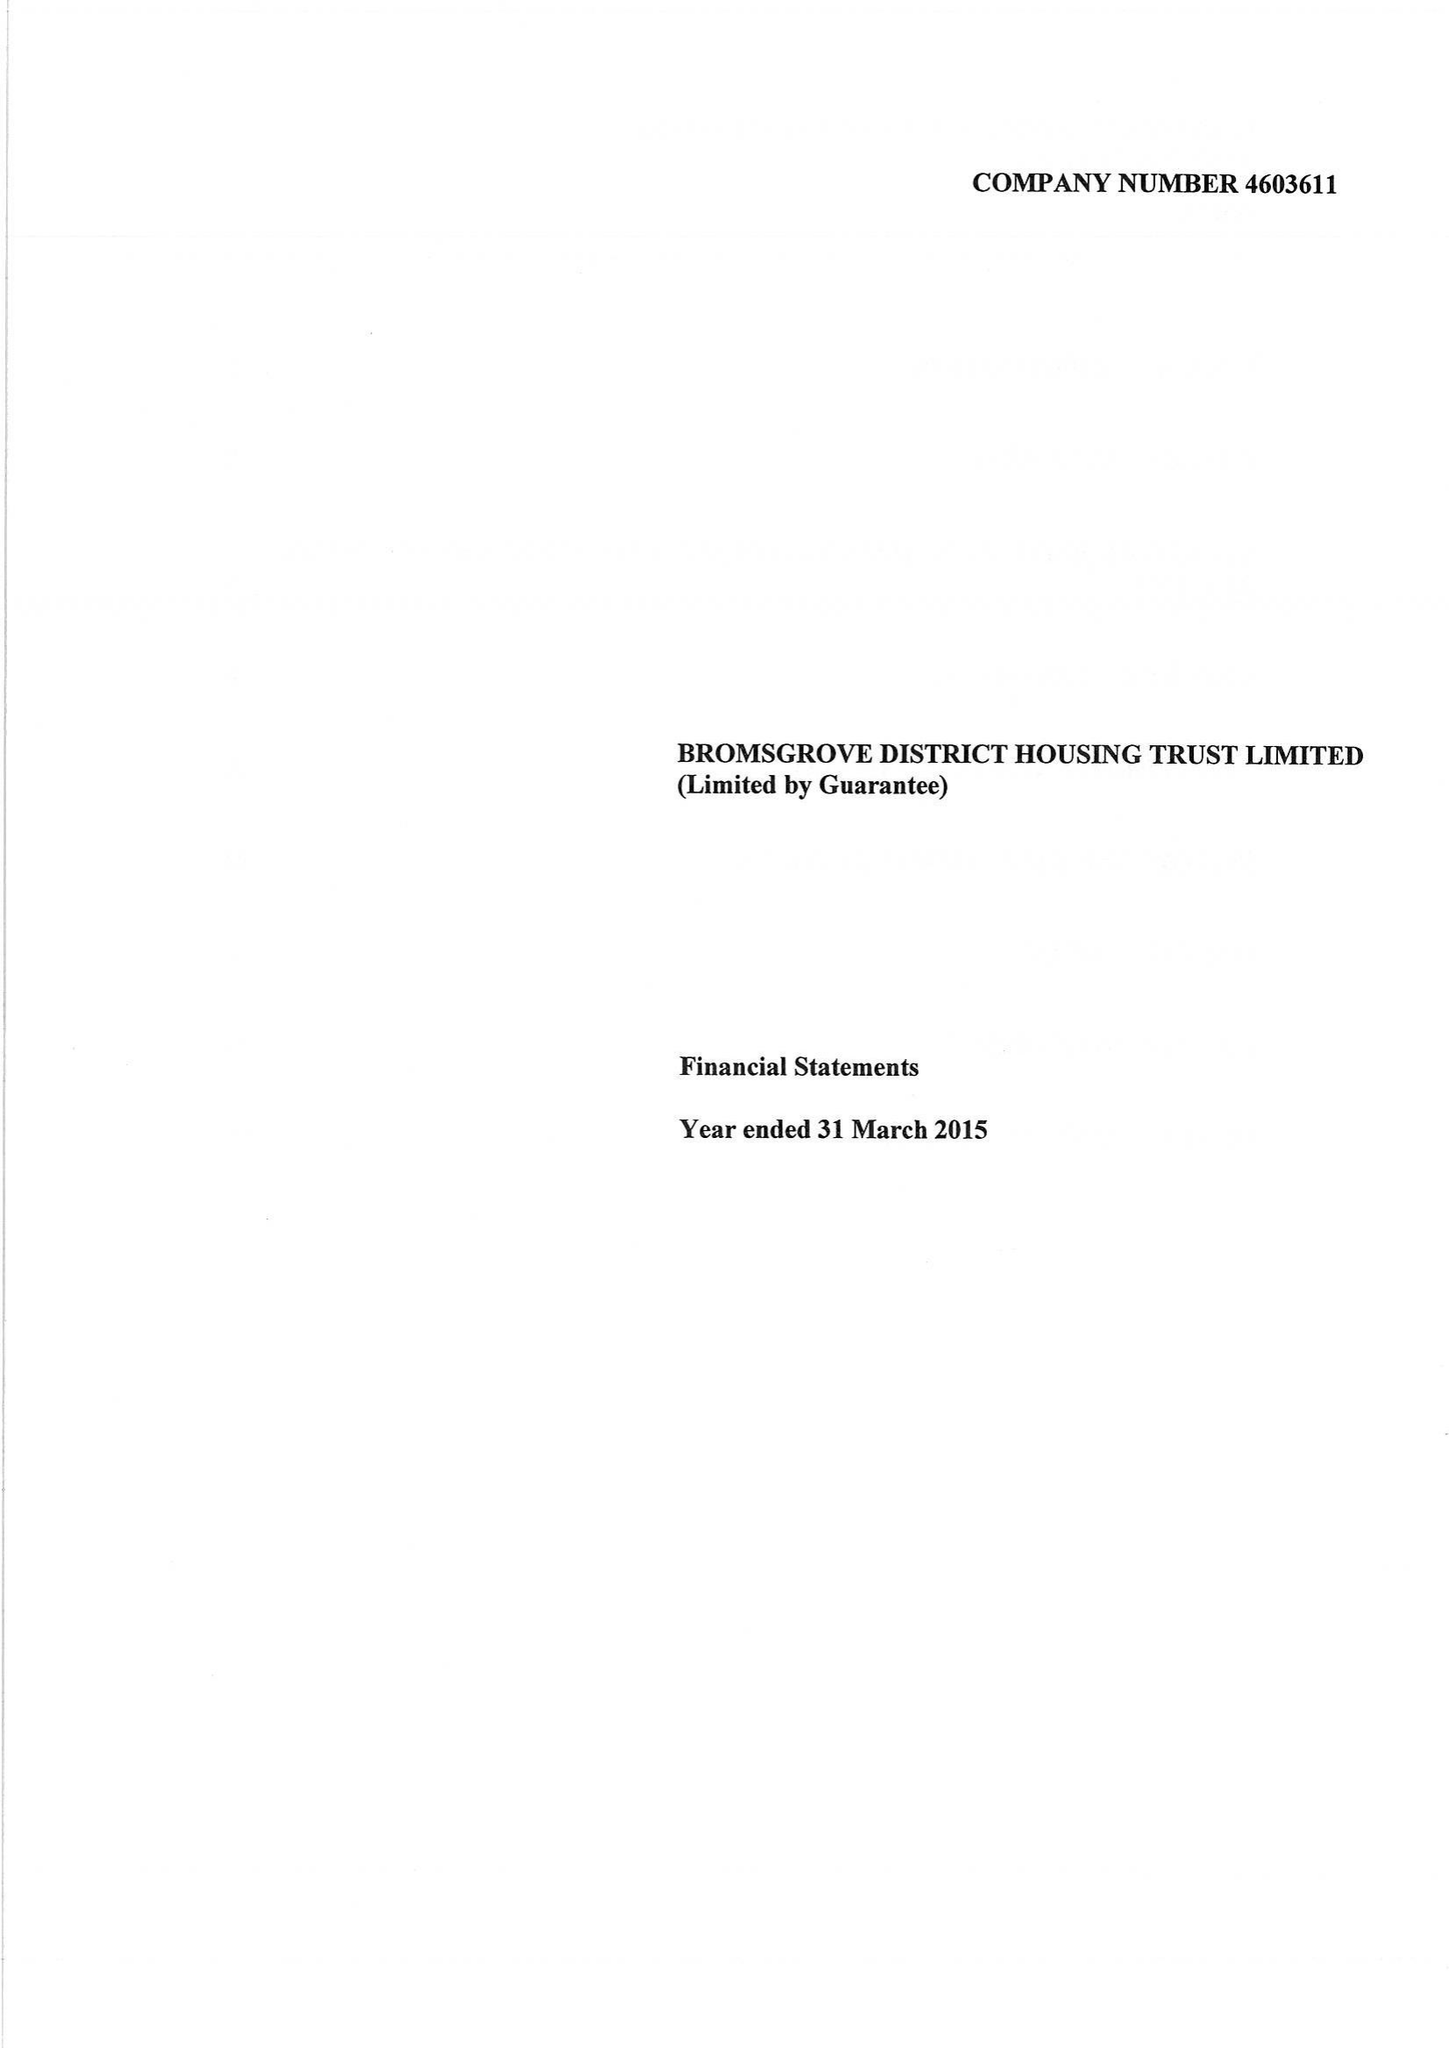What is the value for the address__post_town?
Answer the question using a single word or phrase. BROMSGROVE 